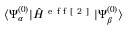Convert formula to latex. <formula><loc_0><loc_0><loc_500><loc_500>\langle \Psi _ { \alpha } ^ { ( 0 ) } | \hat { H } ^ { e f f [ 2 ] } | \Psi _ { \beta } ^ { ( 0 ) } \rangle</formula> 